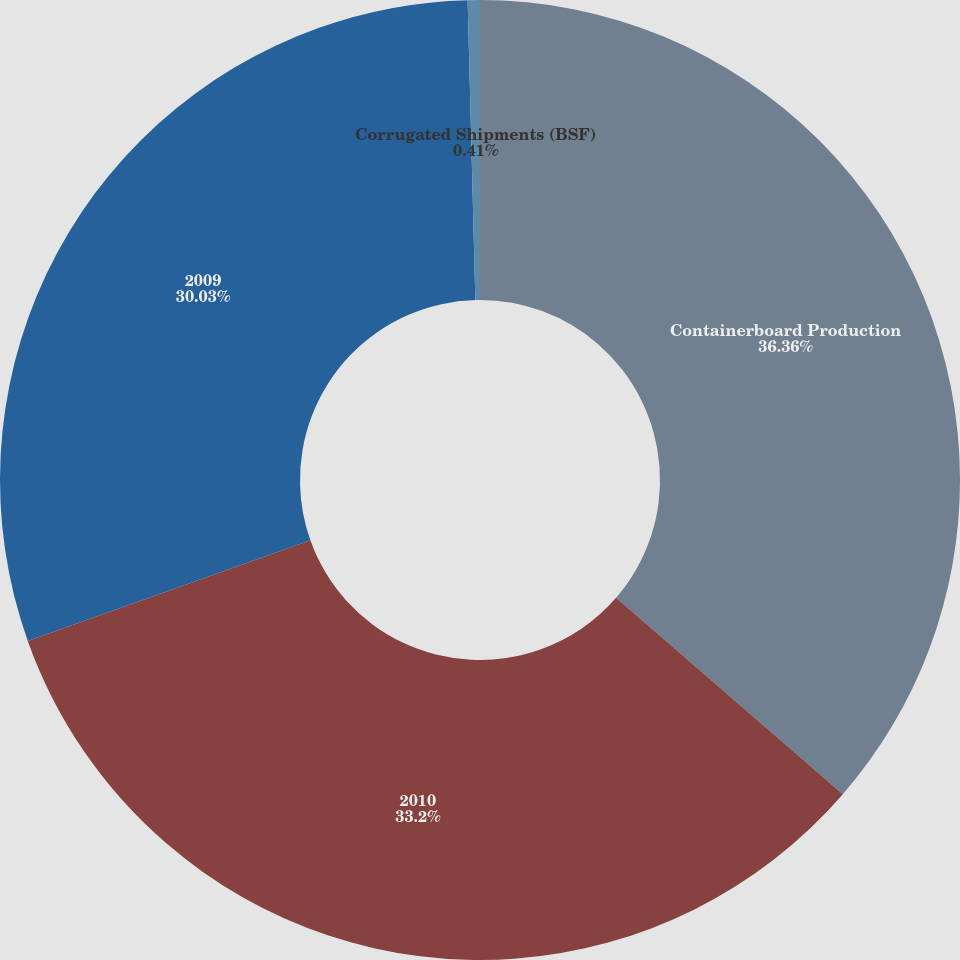Convert chart. <chart><loc_0><loc_0><loc_500><loc_500><pie_chart><fcel>Containerboard Production<fcel>2010<fcel>2009<fcel>Corrugated Shipments (BSF)<nl><fcel>36.36%<fcel>33.2%<fcel>30.03%<fcel>0.41%<nl></chart> 